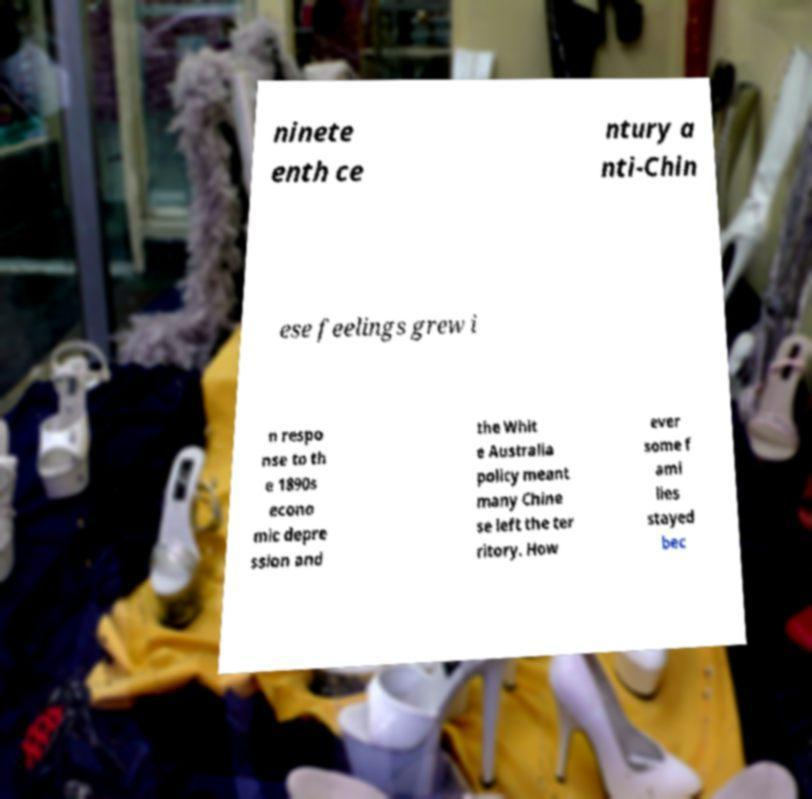There's text embedded in this image that I need extracted. Can you transcribe it verbatim? ninete enth ce ntury a nti-Chin ese feelings grew i n respo nse to th e 1890s econo mic depre ssion and the Whit e Australia policy meant many Chine se left the ter ritory. How ever some f ami lies stayed bec 